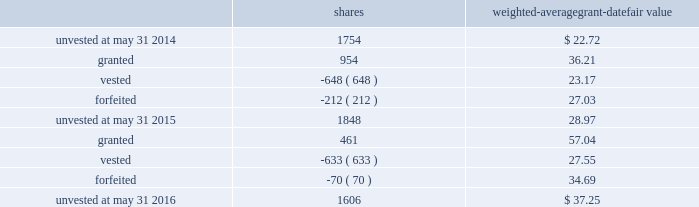Leveraged performance units during fiscal 2015 , certain executives were granted performance units that we refer to as leveraged performance units , or lpus .
Lpus contain a market condition based on our relative stock price growth over a three-year performance period .
The lpus contain a minimum threshold performance which , if not met , would result in no payout .
The lpus also contain a maximum award opportunity set as a fixed dollar and fixed number of shares .
After the three-year performance period , one-third of any earned units converts to unrestricted common stock .
The remaining two-thirds convert to restricted stock that will vest in equal installments on each of the first two anniversaries of the conversion date .
We recognize share-based compensation expense based on the grant date fair value of the lpus , as determined by use of a monte carlo model , on a straight-line basis over the requisite service period for each separately vesting portion of the lpu award .
Total shareholder return units before fiscal 2015 , certain of our executives were granted total shareholder return ( 201ctsr 201d ) units , which are performance-based restricted stock units that are earned based on our total shareholder return over a three-year performance period compared to companies in the s&p 500 .
Once the performance results are certified , tsr units convert into unrestricted common stock .
Depending on our performance , the grantee may earn up to 200% ( 200 % ) of the target number of shares .
The target number of tsr units for each executive is set by the compensation committee .
We recognize share-based compensation expense based on the grant date fair value of the tsr units , as determined by use of a monte carlo model , on a straight-line basis over the vesting period .
The table summarizes the changes in unvested share-based awards for the years ended may 31 , 2016 and 2015 ( shares in thousands ) : shares weighted-average grant-date fair value .
Including the restricted stock , performance units and tsr units described above , the total fair value of share- based awards vested during the years ended may 31 , 2016 , 2015 and 2014 was $ 17.4 million , $ 15.0 million and $ 28.7 million , respectively .
For these share-based awards , we recognized compensation expense of $ 28.8 million , $ 19.8 million and $ 28.2 million in the years ended may 31 , 2016 , 2015 and 2014 , respectively .
As of may 31 , 2016 , there was $ 42.6 million of unrecognized compensation expense related to unvested share-based awards that we expect to recognize over a weighted-average period of 1.9 years .
Our share-based award plans provide for accelerated vesting under certain conditions .
Employee stock purchase plan we have an employee stock purchase plan under which the sale of 4.8 million shares of our common stock has been authorized .
Employees may designate up to the lesser of $ 25000 or 20% ( 20 % ) of their annual compensation for the purchase of our common stock .
The price for shares purchased under the plan is 85% ( 85 % ) of the market value on 84 2013 global payments inc .
| 2016 form 10-k annual report .
What is the total fair value of vested shares in 2016? 
Computations: (633 * 27.55)
Answer: 17439.15. Leveraged performance units during fiscal 2015 , certain executives were granted performance units that we refer to as leveraged performance units , or lpus .
Lpus contain a market condition based on our relative stock price growth over a three-year performance period .
The lpus contain a minimum threshold performance which , if not met , would result in no payout .
The lpus also contain a maximum award opportunity set as a fixed dollar and fixed number of shares .
After the three-year performance period , one-third of any earned units converts to unrestricted common stock .
The remaining two-thirds convert to restricted stock that will vest in equal installments on each of the first two anniversaries of the conversion date .
We recognize share-based compensation expense based on the grant date fair value of the lpus , as determined by use of a monte carlo model , on a straight-line basis over the requisite service period for each separately vesting portion of the lpu award .
Total shareholder return units before fiscal 2015 , certain of our executives were granted total shareholder return ( 201ctsr 201d ) units , which are performance-based restricted stock units that are earned based on our total shareholder return over a three-year performance period compared to companies in the s&p 500 .
Once the performance results are certified , tsr units convert into unrestricted common stock .
Depending on our performance , the grantee may earn up to 200% ( 200 % ) of the target number of shares .
The target number of tsr units for each executive is set by the compensation committee .
We recognize share-based compensation expense based on the grant date fair value of the tsr units , as determined by use of a monte carlo model , on a straight-line basis over the vesting period .
The table summarizes the changes in unvested share-based awards for the years ended may 31 , 2016 and 2015 ( shares in thousands ) : shares weighted-average grant-date fair value .
Including the restricted stock , performance units and tsr units described above , the total fair value of share- based awards vested during the years ended may 31 , 2016 , 2015 and 2014 was $ 17.4 million , $ 15.0 million and $ 28.7 million , respectively .
For these share-based awards , we recognized compensation expense of $ 28.8 million , $ 19.8 million and $ 28.2 million in the years ended may 31 , 2016 , 2015 and 2014 , respectively .
As of may 31 , 2016 , there was $ 42.6 million of unrecognized compensation expense related to unvested share-based awards that we expect to recognize over a weighted-average period of 1.9 years .
Our share-based award plans provide for accelerated vesting under certain conditions .
Employee stock purchase plan we have an employee stock purchase plan under which the sale of 4.8 million shares of our common stock has been authorized .
Employees may designate up to the lesser of $ 25000 or 20% ( 20 % ) of their annual compensation for the purchase of our common stock .
The price for shares purchased under the plan is 85% ( 85 % ) of the market value on 84 2013 global payments inc .
| 2016 form 10-k annual report .
What is the total fair value balance of unvested shares as of may 2016? 
Computations: (1606 - 37.25)
Answer: 1568.75. 